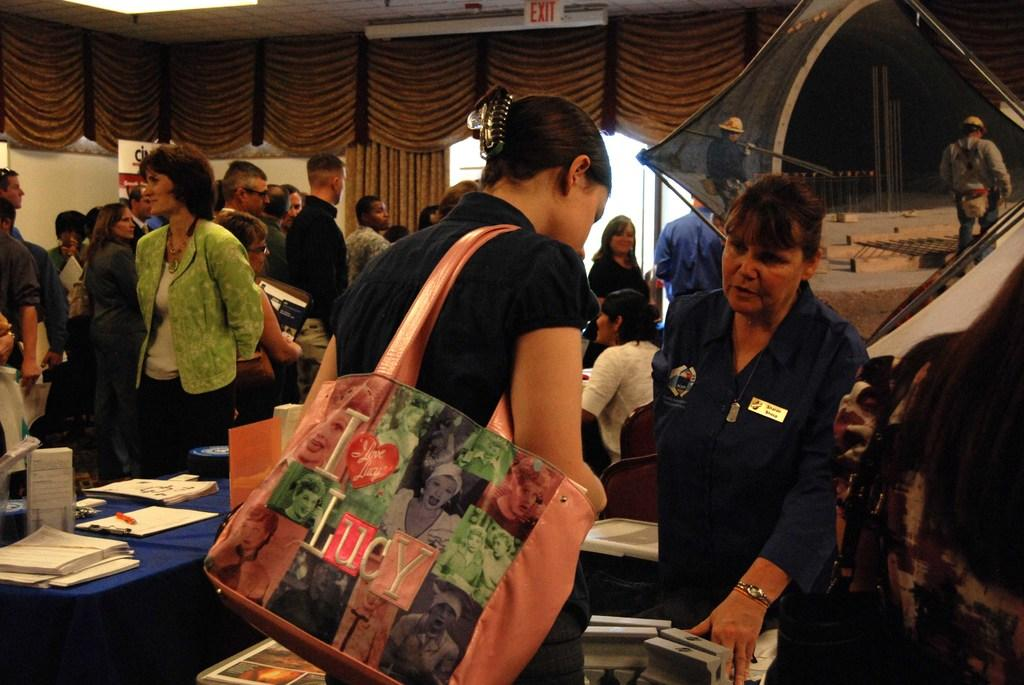What is happening in the image involving the group of people? There is a group of people standing in the image. What items can be seen on the table in the image? There are papers, a pen, and a wooden pad on the table. What type of furniture is present in the image? There are boards and chairs in the image. What can be seen in the background of the image? There are objects visible in the background of the image. Is there a cave visible in the image? No, there is no cave present in the image. What is the temperature of the room in the image? The temperature of the room is not mentioned in the image, so it cannot be determined. 